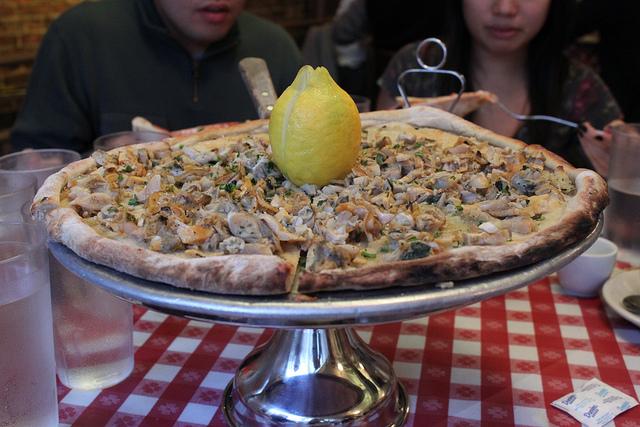How many slices are left?
Keep it brief. 8. What's for lunch?
Write a very short answer. Pizza. What is in the middle of the pizza?
Be succinct. Lemon. How much of the pizza has been eaten already?
Short answer required. 0. How many slices of pizza are there?
Concise answer only. 8. What toppings does the pizza have?
Short answer required. Meat and mushrooms. What color is the tablecloth?
Quick response, please. Red and white. 